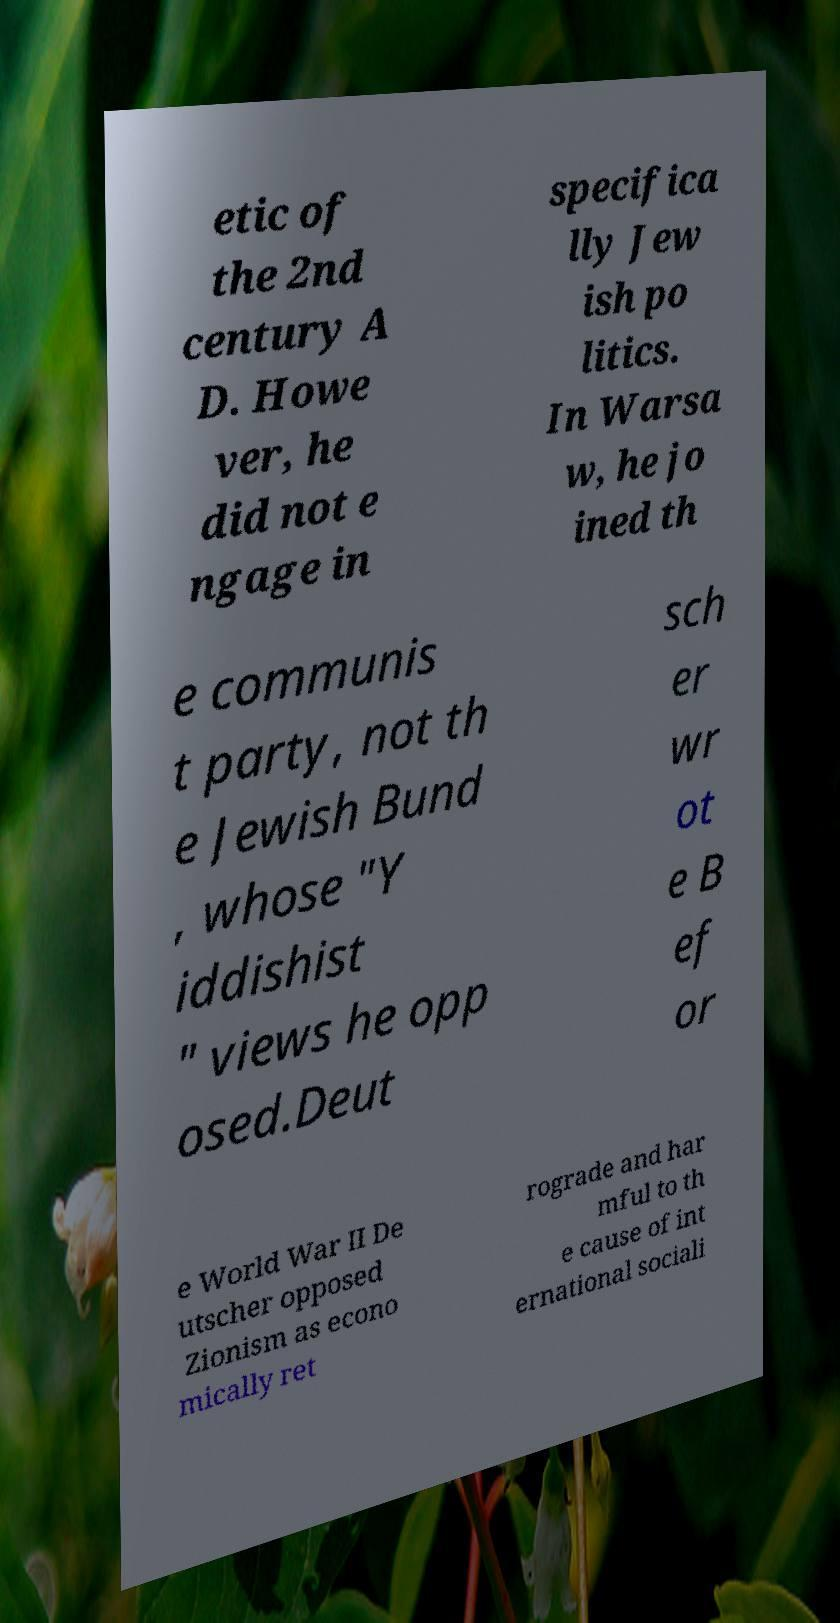Can you accurately transcribe the text from the provided image for me? etic of the 2nd century A D. Howe ver, he did not e ngage in specifica lly Jew ish po litics. In Warsa w, he jo ined th e communis t party, not th e Jewish Bund , whose "Y iddishist " views he opp osed.Deut sch er wr ot e B ef or e World War II De utscher opposed Zionism as econo mically ret rograde and har mful to th e cause of int ernational sociali 